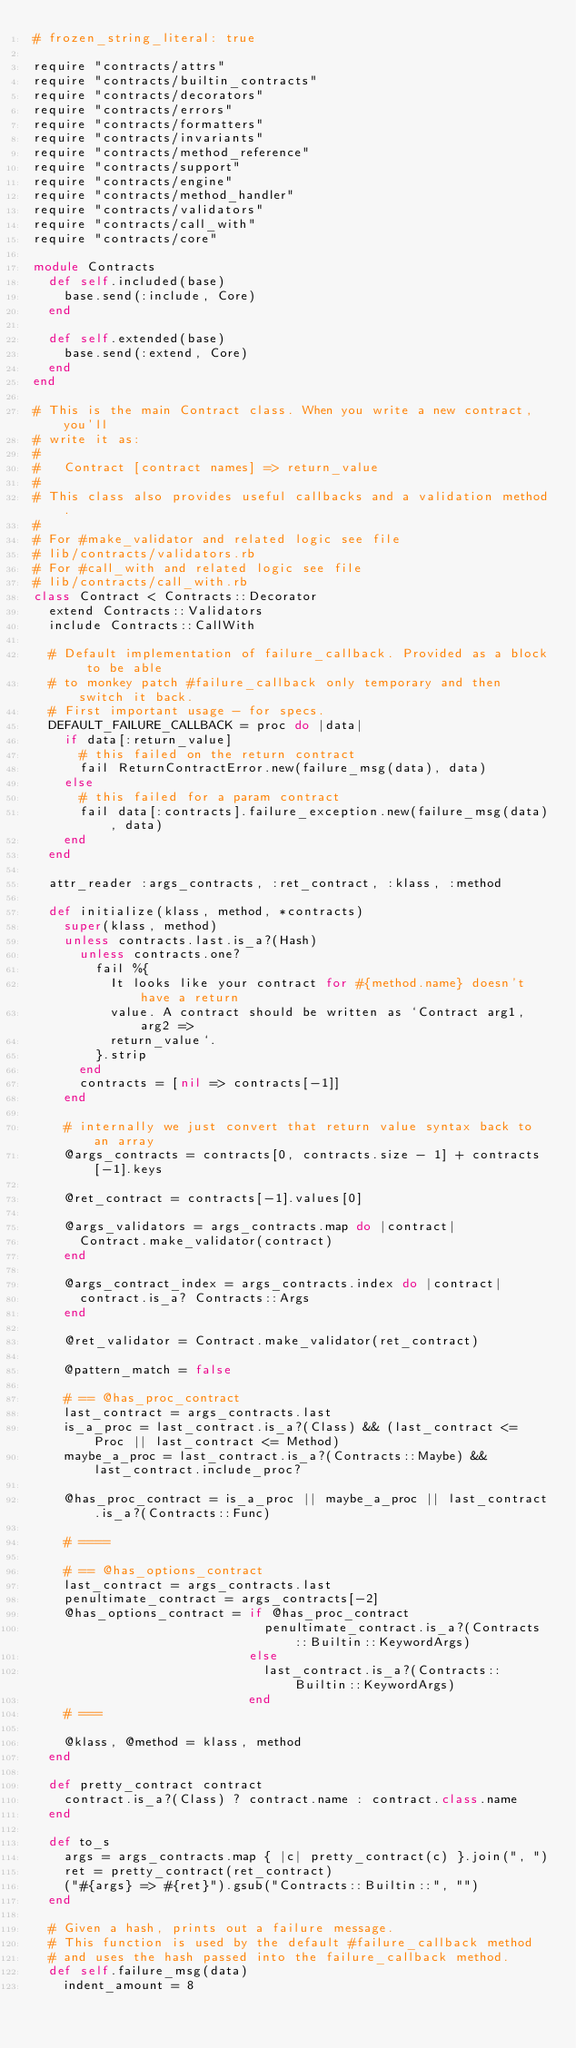<code> <loc_0><loc_0><loc_500><loc_500><_Ruby_># frozen_string_literal: true

require "contracts/attrs"
require "contracts/builtin_contracts"
require "contracts/decorators"
require "contracts/errors"
require "contracts/formatters"
require "contracts/invariants"
require "contracts/method_reference"
require "contracts/support"
require "contracts/engine"
require "contracts/method_handler"
require "contracts/validators"
require "contracts/call_with"
require "contracts/core"

module Contracts
  def self.included(base)
    base.send(:include, Core)
  end

  def self.extended(base)
    base.send(:extend, Core)
  end
end

# This is the main Contract class. When you write a new contract, you'll
# write it as:
#
#   Contract [contract names] => return_value
#
# This class also provides useful callbacks and a validation method.
#
# For #make_validator and related logic see file
# lib/contracts/validators.rb
# For #call_with and related logic see file
# lib/contracts/call_with.rb
class Contract < Contracts::Decorator
  extend Contracts::Validators
  include Contracts::CallWith

  # Default implementation of failure_callback. Provided as a block to be able
  # to monkey patch #failure_callback only temporary and then switch it back.
  # First important usage - for specs.
  DEFAULT_FAILURE_CALLBACK = proc do |data|
    if data[:return_value]
      # this failed on the return contract
      fail ReturnContractError.new(failure_msg(data), data)
    else
      # this failed for a param contract
      fail data[:contracts].failure_exception.new(failure_msg(data), data)
    end
  end

  attr_reader :args_contracts, :ret_contract, :klass, :method

  def initialize(klass, method, *contracts)
    super(klass, method)
    unless contracts.last.is_a?(Hash)
      unless contracts.one?
        fail %{
          It looks like your contract for #{method.name} doesn't have a return
          value. A contract should be written as `Contract arg1, arg2 =>
          return_value`.
        }.strip
      end
      contracts = [nil => contracts[-1]]
    end

    # internally we just convert that return value syntax back to an array
    @args_contracts = contracts[0, contracts.size - 1] + contracts[-1].keys

    @ret_contract = contracts[-1].values[0]

    @args_validators = args_contracts.map do |contract|
      Contract.make_validator(contract)
    end

    @args_contract_index = args_contracts.index do |contract|
      contract.is_a? Contracts::Args
    end

    @ret_validator = Contract.make_validator(ret_contract)

    @pattern_match = false

    # == @has_proc_contract
    last_contract = args_contracts.last
    is_a_proc = last_contract.is_a?(Class) && (last_contract <= Proc || last_contract <= Method)
    maybe_a_proc = last_contract.is_a?(Contracts::Maybe) && last_contract.include_proc?

    @has_proc_contract = is_a_proc || maybe_a_proc || last_contract.is_a?(Contracts::Func)

    # ====

    # == @has_options_contract
    last_contract = args_contracts.last
    penultimate_contract = args_contracts[-2]
    @has_options_contract = if @has_proc_contract
                              penultimate_contract.is_a?(Contracts::Builtin::KeywordArgs)
                            else
                              last_contract.is_a?(Contracts::Builtin::KeywordArgs)
                            end
    # ===

    @klass, @method = klass, method
  end

  def pretty_contract contract
    contract.is_a?(Class) ? contract.name : contract.class.name
  end

  def to_s
    args = args_contracts.map { |c| pretty_contract(c) }.join(", ")
    ret = pretty_contract(ret_contract)
    ("#{args} => #{ret}").gsub("Contracts::Builtin::", "")
  end

  # Given a hash, prints out a failure message.
  # This function is used by the default #failure_callback method
  # and uses the hash passed into the failure_callback method.
  def self.failure_msg(data)
    indent_amount = 8</code> 